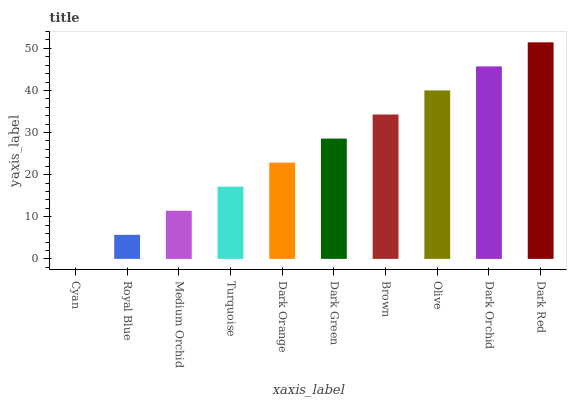Is Cyan the minimum?
Answer yes or no. Yes. Is Dark Red the maximum?
Answer yes or no. Yes. Is Royal Blue the minimum?
Answer yes or no. No. Is Royal Blue the maximum?
Answer yes or no. No. Is Royal Blue greater than Cyan?
Answer yes or no. Yes. Is Cyan less than Royal Blue?
Answer yes or no. Yes. Is Cyan greater than Royal Blue?
Answer yes or no. No. Is Royal Blue less than Cyan?
Answer yes or no. No. Is Dark Green the high median?
Answer yes or no. Yes. Is Dark Orange the low median?
Answer yes or no. Yes. Is Dark Orchid the high median?
Answer yes or no. No. Is Dark Red the low median?
Answer yes or no. No. 